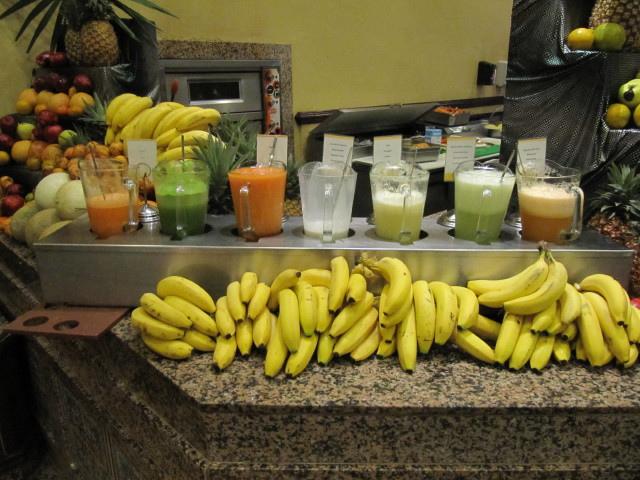Are the bananas for sale?
Be succinct. No. Are they having bananas?
Keep it brief. Yes. What kind of fruit is on the table?
Write a very short answer. Banana. How many beverages are there?
Answer briefly. 7. 